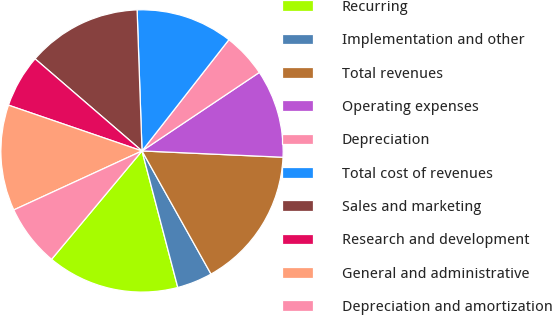Convert chart. <chart><loc_0><loc_0><loc_500><loc_500><pie_chart><fcel>Recurring<fcel>Implementation and other<fcel>Total revenues<fcel>Operating expenses<fcel>Depreciation<fcel>Total cost of revenues<fcel>Sales and marketing<fcel>Research and development<fcel>General and administrative<fcel>Depreciation and amortization<nl><fcel>15.15%<fcel>4.05%<fcel>16.16%<fcel>10.1%<fcel>5.06%<fcel>11.11%<fcel>13.13%<fcel>6.06%<fcel>12.12%<fcel>7.07%<nl></chart> 